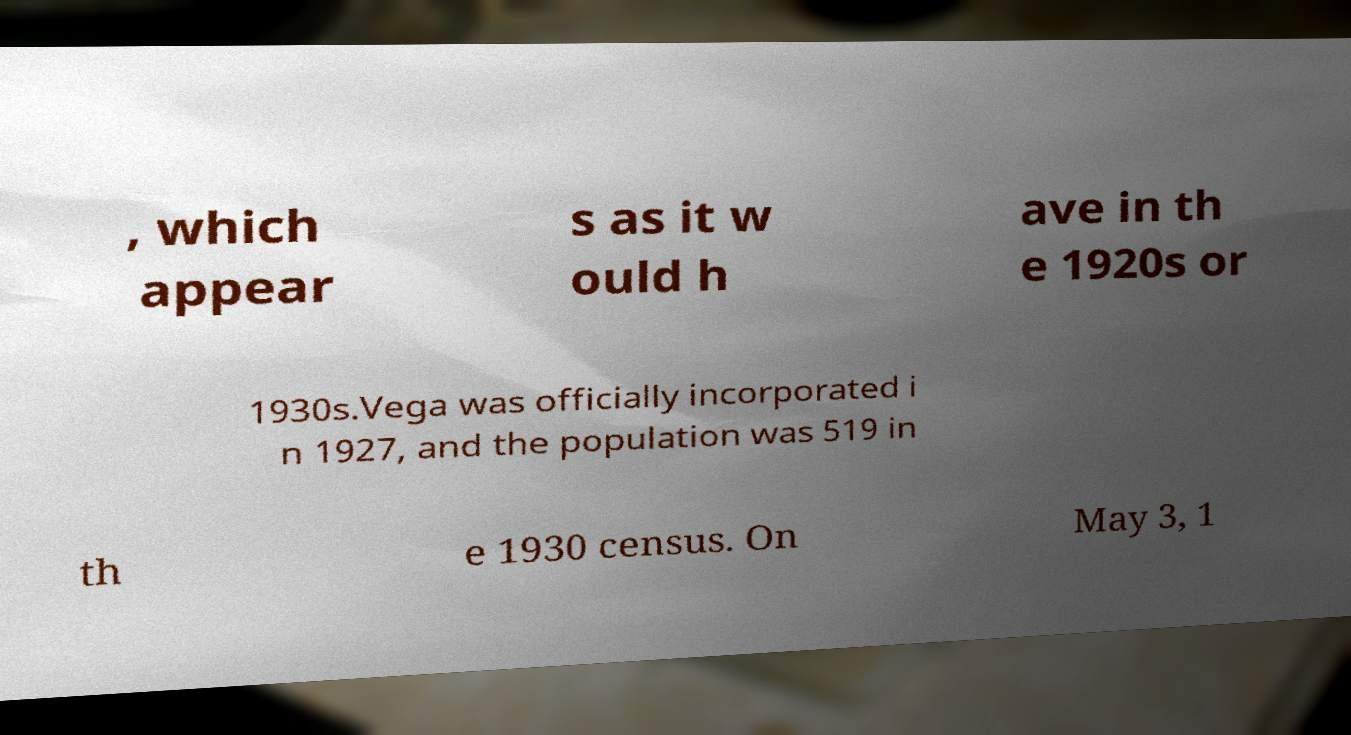There's text embedded in this image that I need extracted. Can you transcribe it verbatim? , which appear s as it w ould h ave in th e 1920s or 1930s.Vega was officially incorporated i n 1927, and the population was 519 in th e 1930 census. On May 3, 1 